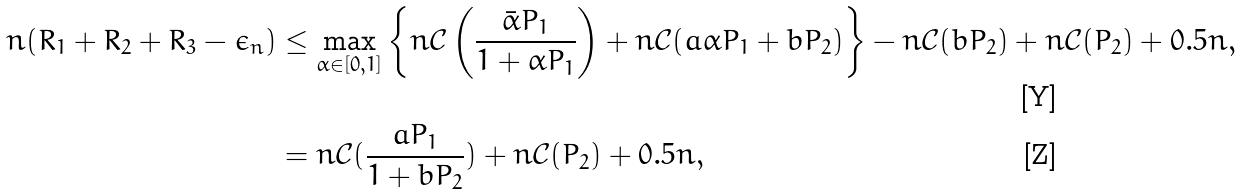<formula> <loc_0><loc_0><loc_500><loc_500>n ( R _ { 1 } + R _ { 2 } + R _ { 3 } - \epsilon _ { n } ) & \leq \max _ { \alpha \in [ 0 , 1 ] } \left \{ n \mathcal { C } \left ( \frac { \bar { \alpha } P _ { 1 } } { 1 + \alpha P _ { 1 } } \right ) + n \mathcal { C } ( a \alpha P _ { 1 } + b P _ { 2 } ) \right \} - n \mathcal { C } ( b P _ { 2 } ) + n \mathcal { C } ( P _ { 2 } ) + 0 . 5 n , \\ & = n \mathcal { C } ( \frac { a P _ { 1 } } { 1 + b P _ { 2 } } ) + n \mathcal { C } ( P _ { 2 } ) + 0 . 5 n ,</formula> 